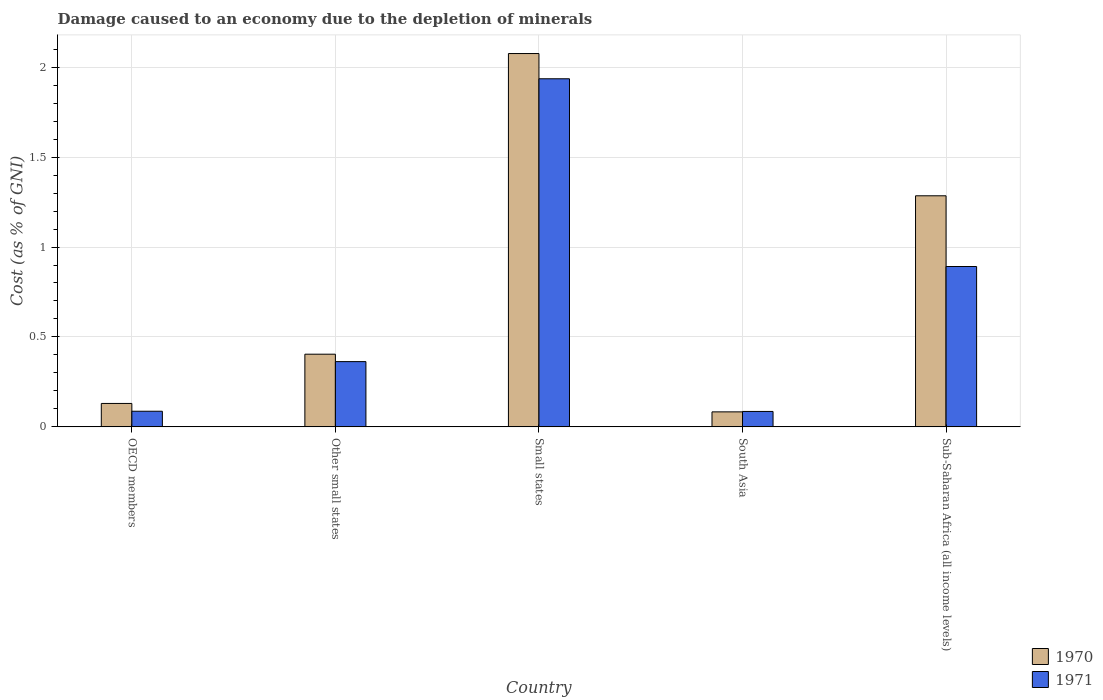How many different coloured bars are there?
Your answer should be very brief. 2. How many bars are there on the 4th tick from the right?
Your answer should be very brief. 2. What is the label of the 3rd group of bars from the left?
Provide a short and direct response. Small states. What is the cost of damage caused due to the depletion of minerals in 1970 in Small states?
Keep it short and to the point. 2.08. Across all countries, what is the maximum cost of damage caused due to the depletion of minerals in 1970?
Give a very brief answer. 2.08. Across all countries, what is the minimum cost of damage caused due to the depletion of minerals in 1970?
Make the answer very short. 0.08. In which country was the cost of damage caused due to the depletion of minerals in 1970 maximum?
Ensure brevity in your answer.  Small states. In which country was the cost of damage caused due to the depletion of minerals in 1971 minimum?
Keep it short and to the point. South Asia. What is the total cost of damage caused due to the depletion of minerals in 1971 in the graph?
Provide a short and direct response. 3.36. What is the difference between the cost of damage caused due to the depletion of minerals in 1970 in Small states and that in Sub-Saharan Africa (all income levels)?
Your answer should be very brief. 0.79. What is the difference between the cost of damage caused due to the depletion of minerals in 1970 in Other small states and the cost of damage caused due to the depletion of minerals in 1971 in South Asia?
Offer a very short reply. 0.32. What is the average cost of damage caused due to the depletion of minerals in 1971 per country?
Offer a terse response. 0.67. What is the difference between the cost of damage caused due to the depletion of minerals of/in 1970 and cost of damage caused due to the depletion of minerals of/in 1971 in Other small states?
Provide a short and direct response. 0.04. In how many countries, is the cost of damage caused due to the depletion of minerals in 1971 greater than 1.2 %?
Offer a very short reply. 1. What is the ratio of the cost of damage caused due to the depletion of minerals in 1970 in Small states to that in South Asia?
Give a very brief answer. 24.88. What is the difference between the highest and the second highest cost of damage caused due to the depletion of minerals in 1971?
Your response must be concise. -1.04. What is the difference between the highest and the lowest cost of damage caused due to the depletion of minerals in 1970?
Your response must be concise. 1.99. Are the values on the major ticks of Y-axis written in scientific E-notation?
Keep it short and to the point. No. Does the graph contain any zero values?
Your answer should be very brief. No. Where does the legend appear in the graph?
Give a very brief answer. Bottom right. How many legend labels are there?
Provide a short and direct response. 2. How are the legend labels stacked?
Your answer should be very brief. Vertical. What is the title of the graph?
Ensure brevity in your answer.  Damage caused to an economy due to the depletion of minerals. What is the label or title of the Y-axis?
Offer a terse response. Cost (as % of GNI). What is the Cost (as % of GNI) of 1970 in OECD members?
Your answer should be very brief. 0.13. What is the Cost (as % of GNI) of 1971 in OECD members?
Make the answer very short. 0.09. What is the Cost (as % of GNI) of 1970 in Other small states?
Ensure brevity in your answer.  0.4. What is the Cost (as % of GNI) in 1971 in Other small states?
Provide a short and direct response. 0.36. What is the Cost (as % of GNI) of 1970 in Small states?
Offer a terse response. 2.08. What is the Cost (as % of GNI) of 1971 in Small states?
Make the answer very short. 1.94. What is the Cost (as % of GNI) of 1970 in South Asia?
Provide a succinct answer. 0.08. What is the Cost (as % of GNI) in 1971 in South Asia?
Keep it short and to the point. 0.09. What is the Cost (as % of GNI) in 1970 in Sub-Saharan Africa (all income levels)?
Provide a short and direct response. 1.28. What is the Cost (as % of GNI) in 1971 in Sub-Saharan Africa (all income levels)?
Give a very brief answer. 0.89. Across all countries, what is the maximum Cost (as % of GNI) in 1970?
Ensure brevity in your answer.  2.08. Across all countries, what is the maximum Cost (as % of GNI) in 1971?
Your answer should be very brief. 1.94. Across all countries, what is the minimum Cost (as % of GNI) in 1970?
Offer a terse response. 0.08. Across all countries, what is the minimum Cost (as % of GNI) in 1971?
Provide a succinct answer. 0.09. What is the total Cost (as % of GNI) of 1970 in the graph?
Provide a succinct answer. 3.98. What is the total Cost (as % of GNI) in 1971 in the graph?
Make the answer very short. 3.36. What is the difference between the Cost (as % of GNI) in 1970 in OECD members and that in Other small states?
Make the answer very short. -0.27. What is the difference between the Cost (as % of GNI) of 1971 in OECD members and that in Other small states?
Make the answer very short. -0.28. What is the difference between the Cost (as % of GNI) of 1970 in OECD members and that in Small states?
Offer a very short reply. -1.95. What is the difference between the Cost (as % of GNI) in 1971 in OECD members and that in Small states?
Your answer should be compact. -1.85. What is the difference between the Cost (as % of GNI) of 1970 in OECD members and that in South Asia?
Offer a very short reply. 0.05. What is the difference between the Cost (as % of GNI) in 1971 in OECD members and that in South Asia?
Give a very brief answer. 0. What is the difference between the Cost (as % of GNI) in 1970 in OECD members and that in Sub-Saharan Africa (all income levels)?
Offer a very short reply. -1.15. What is the difference between the Cost (as % of GNI) in 1971 in OECD members and that in Sub-Saharan Africa (all income levels)?
Offer a terse response. -0.8. What is the difference between the Cost (as % of GNI) of 1970 in Other small states and that in Small states?
Keep it short and to the point. -1.67. What is the difference between the Cost (as % of GNI) in 1971 in Other small states and that in Small states?
Your answer should be compact. -1.57. What is the difference between the Cost (as % of GNI) of 1970 in Other small states and that in South Asia?
Your answer should be compact. 0.32. What is the difference between the Cost (as % of GNI) of 1971 in Other small states and that in South Asia?
Provide a short and direct response. 0.28. What is the difference between the Cost (as % of GNI) of 1970 in Other small states and that in Sub-Saharan Africa (all income levels)?
Make the answer very short. -0.88. What is the difference between the Cost (as % of GNI) of 1971 in Other small states and that in Sub-Saharan Africa (all income levels)?
Make the answer very short. -0.53. What is the difference between the Cost (as % of GNI) in 1970 in Small states and that in South Asia?
Make the answer very short. 1.99. What is the difference between the Cost (as % of GNI) in 1971 in Small states and that in South Asia?
Your response must be concise. 1.85. What is the difference between the Cost (as % of GNI) of 1970 in Small states and that in Sub-Saharan Africa (all income levels)?
Your response must be concise. 0.79. What is the difference between the Cost (as % of GNI) of 1971 in Small states and that in Sub-Saharan Africa (all income levels)?
Offer a terse response. 1.04. What is the difference between the Cost (as % of GNI) in 1970 in South Asia and that in Sub-Saharan Africa (all income levels)?
Keep it short and to the point. -1.2. What is the difference between the Cost (as % of GNI) of 1971 in South Asia and that in Sub-Saharan Africa (all income levels)?
Provide a short and direct response. -0.81. What is the difference between the Cost (as % of GNI) of 1970 in OECD members and the Cost (as % of GNI) of 1971 in Other small states?
Provide a succinct answer. -0.23. What is the difference between the Cost (as % of GNI) of 1970 in OECD members and the Cost (as % of GNI) of 1971 in Small states?
Give a very brief answer. -1.81. What is the difference between the Cost (as % of GNI) in 1970 in OECD members and the Cost (as % of GNI) in 1971 in South Asia?
Your answer should be very brief. 0.04. What is the difference between the Cost (as % of GNI) in 1970 in OECD members and the Cost (as % of GNI) in 1971 in Sub-Saharan Africa (all income levels)?
Give a very brief answer. -0.76. What is the difference between the Cost (as % of GNI) of 1970 in Other small states and the Cost (as % of GNI) of 1971 in Small states?
Ensure brevity in your answer.  -1.53. What is the difference between the Cost (as % of GNI) of 1970 in Other small states and the Cost (as % of GNI) of 1971 in South Asia?
Provide a succinct answer. 0.32. What is the difference between the Cost (as % of GNI) of 1970 in Other small states and the Cost (as % of GNI) of 1971 in Sub-Saharan Africa (all income levels)?
Your answer should be very brief. -0.49. What is the difference between the Cost (as % of GNI) in 1970 in Small states and the Cost (as % of GNI) in 1971 in South Asia?
Your answer should be very brief. 1.99. What is the difference between the Cost (as % of GNI) in 1970 in Small states and the Cost (as % of GNI) in 1971 in Sub-Saharan Africa (all income levels)?
Provide a succinct answer. 1.18. What is the difference between the Cost (as % of GNI) of 1970 in South Asia and the Cost (as % of GNI) of 1971 in Sub-Saharan Africa (all income levels)?
Make the answer very short. -0.81. What is the average Cost (as % of GNI) of 1970 per country?
Offer a terse response. 0.8. What is the average Cost (as % of GNI) in 1971 per country?
Provide a short and direct response. 0.67. What is the difference between the Cost (as % of GNI) in 1970 and Cost (as % of GNI) in 1971 in OECD members?
Offer a very short reply. 0.04. What is the difference between the Cost (as % of GNI) in 1970 and Cost (as % of GNI) in 1971 in Other small states?
Ensure brevity in your answer.  0.04. What is the difference between the Cost (as % of GNI) of 1970 and Cost (as % of GNI) of 1971 in Small states?
Your answer should be very brief. 0.14. What is the difference between the Cost (as % of GNI) of 1970 and Cost (as % of GNI) of 1971 in South Asia?
Keep it short and to the point. -0. What is the difference between the Cost (as % of GNI) of 1970 and Cost (as % of GNI) of 1971 in Sub-Saharan Africa (all income levels)?
Provide a succinct answer. 0.39. What is the ratio of the Cost (as % of GNI) in 1970 in OECD members to that in Other small states?
Provide a short and direct response. 0.32. What is the ratio of the Cost (as % of GNI) in 1971 in OECD members to that in Other small states?
Offer a very short reply. 0.24. What is the ratio of the Cost (as % of GNI) of 1970 in OECD members to that in Small states?
Ensure brevity in your answer.  0.06. What is the ratio of the Cost (as % of GNI) of 1971 in OECD members to that in Small states?
Make the answer very short. 0.04. What is the ratio of the Cost (as % of GNI) in 1970 in OECD members to that in South Asia?
Make the answer very short. 1.56. What is the ratio of the Cost (as % of GNI) of 1971 in OECD members to that in South Asia?
Make the answer very short. 1.01. What is the ratio of the Cost (as % of GNI) of 1970 in OECD members to that in Sub-Saharan Africa (all income levels)?
Provide a short and direct response. 0.1. What is the ratio of the Cost (as % of GNI) in 1971 in OECD members to that in Sub-Saharan Africa (all income levels)?
Your answer should be very brief. 0.1. What is the ratio of the Cost (as % of GNI) in 1970 in Other small states to that in Small states?
Provide a succinct answer. 0.19. What is the ratio of the Cost (as % of GNI) in 1971 in Other small states to that in Small states?
Offer a very short reply. 0.19. What is the ratio of the Cost (as % of GNI) of 1970 in Other small states to that in South Asia?
Offer a terse response. 4.84. What is the ratio of the Cost (as % of GNI) of 1971 in Other small states to that in South Asia?
Ensure brevity in your answer.  4.23. What is the ratio of the Cost (as % of GNI) in 1970 in Other small states to that in Sub-Saharan Africa (all income levels)?
Your response must be concise. 0.31. What is the ratio of the Cost (as % of GNI) of 1971 in Other small states to that in Sub-Saharan Africa (all income levels)?
Ensure brevity in your answer.  0.41. What is the ratio of the Cost (as % of GNI) of 1970 in Small states to that in South Asia?
Your answer should be very brief. 24.88. What is the ratio of the Cost (as % of GNI) of 1971 in Small states to that in South Asia?
Ensure brevity in your answer.  22.57. What is the ratio of the Cost (as % of GNI) in 1970 in Small states to that in Sub-Saharan Africa (all income levels)?
Make the answer very short. 1.62. What is the ratio of the Cost (as % of GNI) of 1971 in Small states to that in Sub-Saharan Africa (all income levels)?
Offer a very short reply. 2.17. What is the ratio of the Cost (as % of GNI) in 1970 in South Asia to that in Sub-Saharan Africa (all income levels)?
Make the answer very short. 0.06. What is the ratio of the Cost (as % of GNI) of 1971 in South Asia to that in Sub-Saharan Africa (all income levels)?
Your answer should be very brief. 0.1. What is the difference between the highest and the second highest Cost (as % of GNI) of 1970?
Your response must be concise. 0.79. What is the difference between the highest and the second highest Cost (as % of GNI) of 1971?
Provide a succinct answer. 1.04. What is the difference between the highest and the lowest Cost (as % of GNI) in 1970?
Give a very brief answer. 1.99. What is the difference between the highest and the lowest Cost (as % of GNI) in 1971?
Offer a terse response. 1.85. 